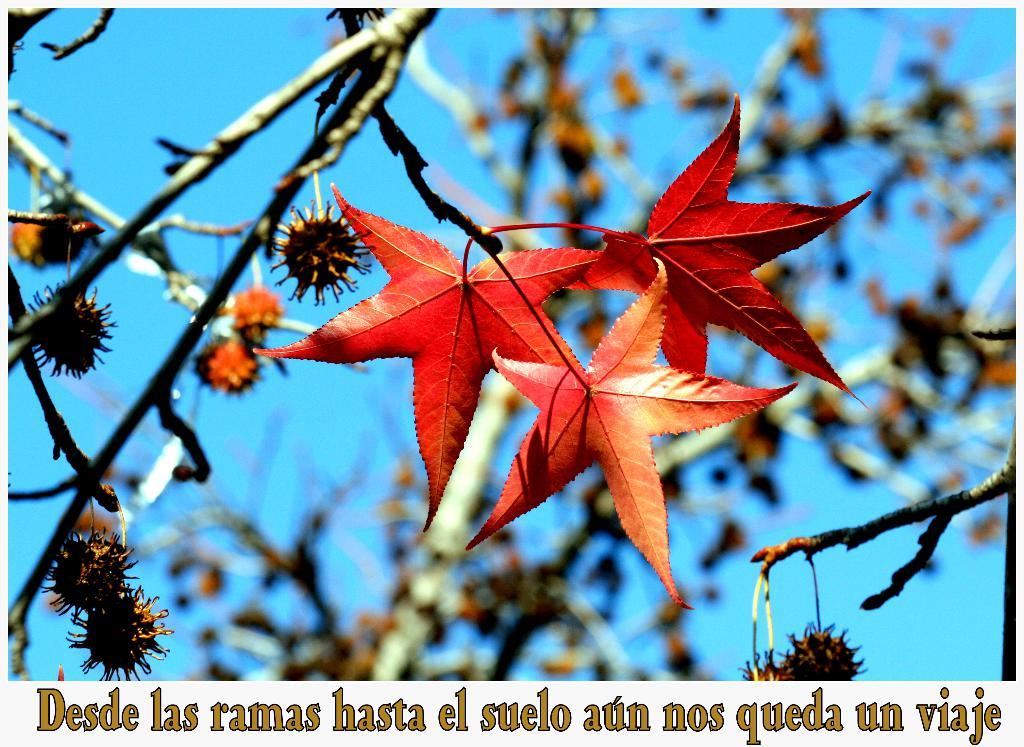What type of vegetation can be seen in the image? There are leaves on the branches of a tree in the image. What can be seen in the background of the image? The sky is visible in the background of the image. Is there any text present in the image? Yes, there is some text at the bottom of the image. What type of cast can be seen on the tree in the image? There is no cast present on the tree in the image. What kind of jar is visible on the branches of the tree? There is no jar present on the branches of the tree in the image. 